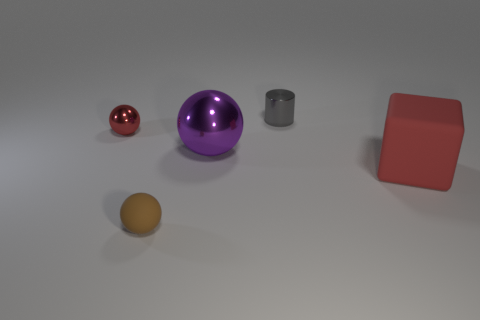What shapes can be identified in the image, and which one is the largest? The image displays a variety of geometric shapes: a small red sphere, a larger purple sphere, a yellow ellipsoid, a silver cylinder, and a red cube. The largest shape, by comparison, appears to be the purple sphere. Can you tell me more about the lighting and shadows in the scene? Certainly! The lighting in the image appears to be diffused, likely from an overhead source, given how the shadows are cast subtly beneath each object. The softness of the shadows suggests the light source is not overly harsh, and the even distribution of shadows indicates that the light is fairly central and possibly slightly in front of the objects. 